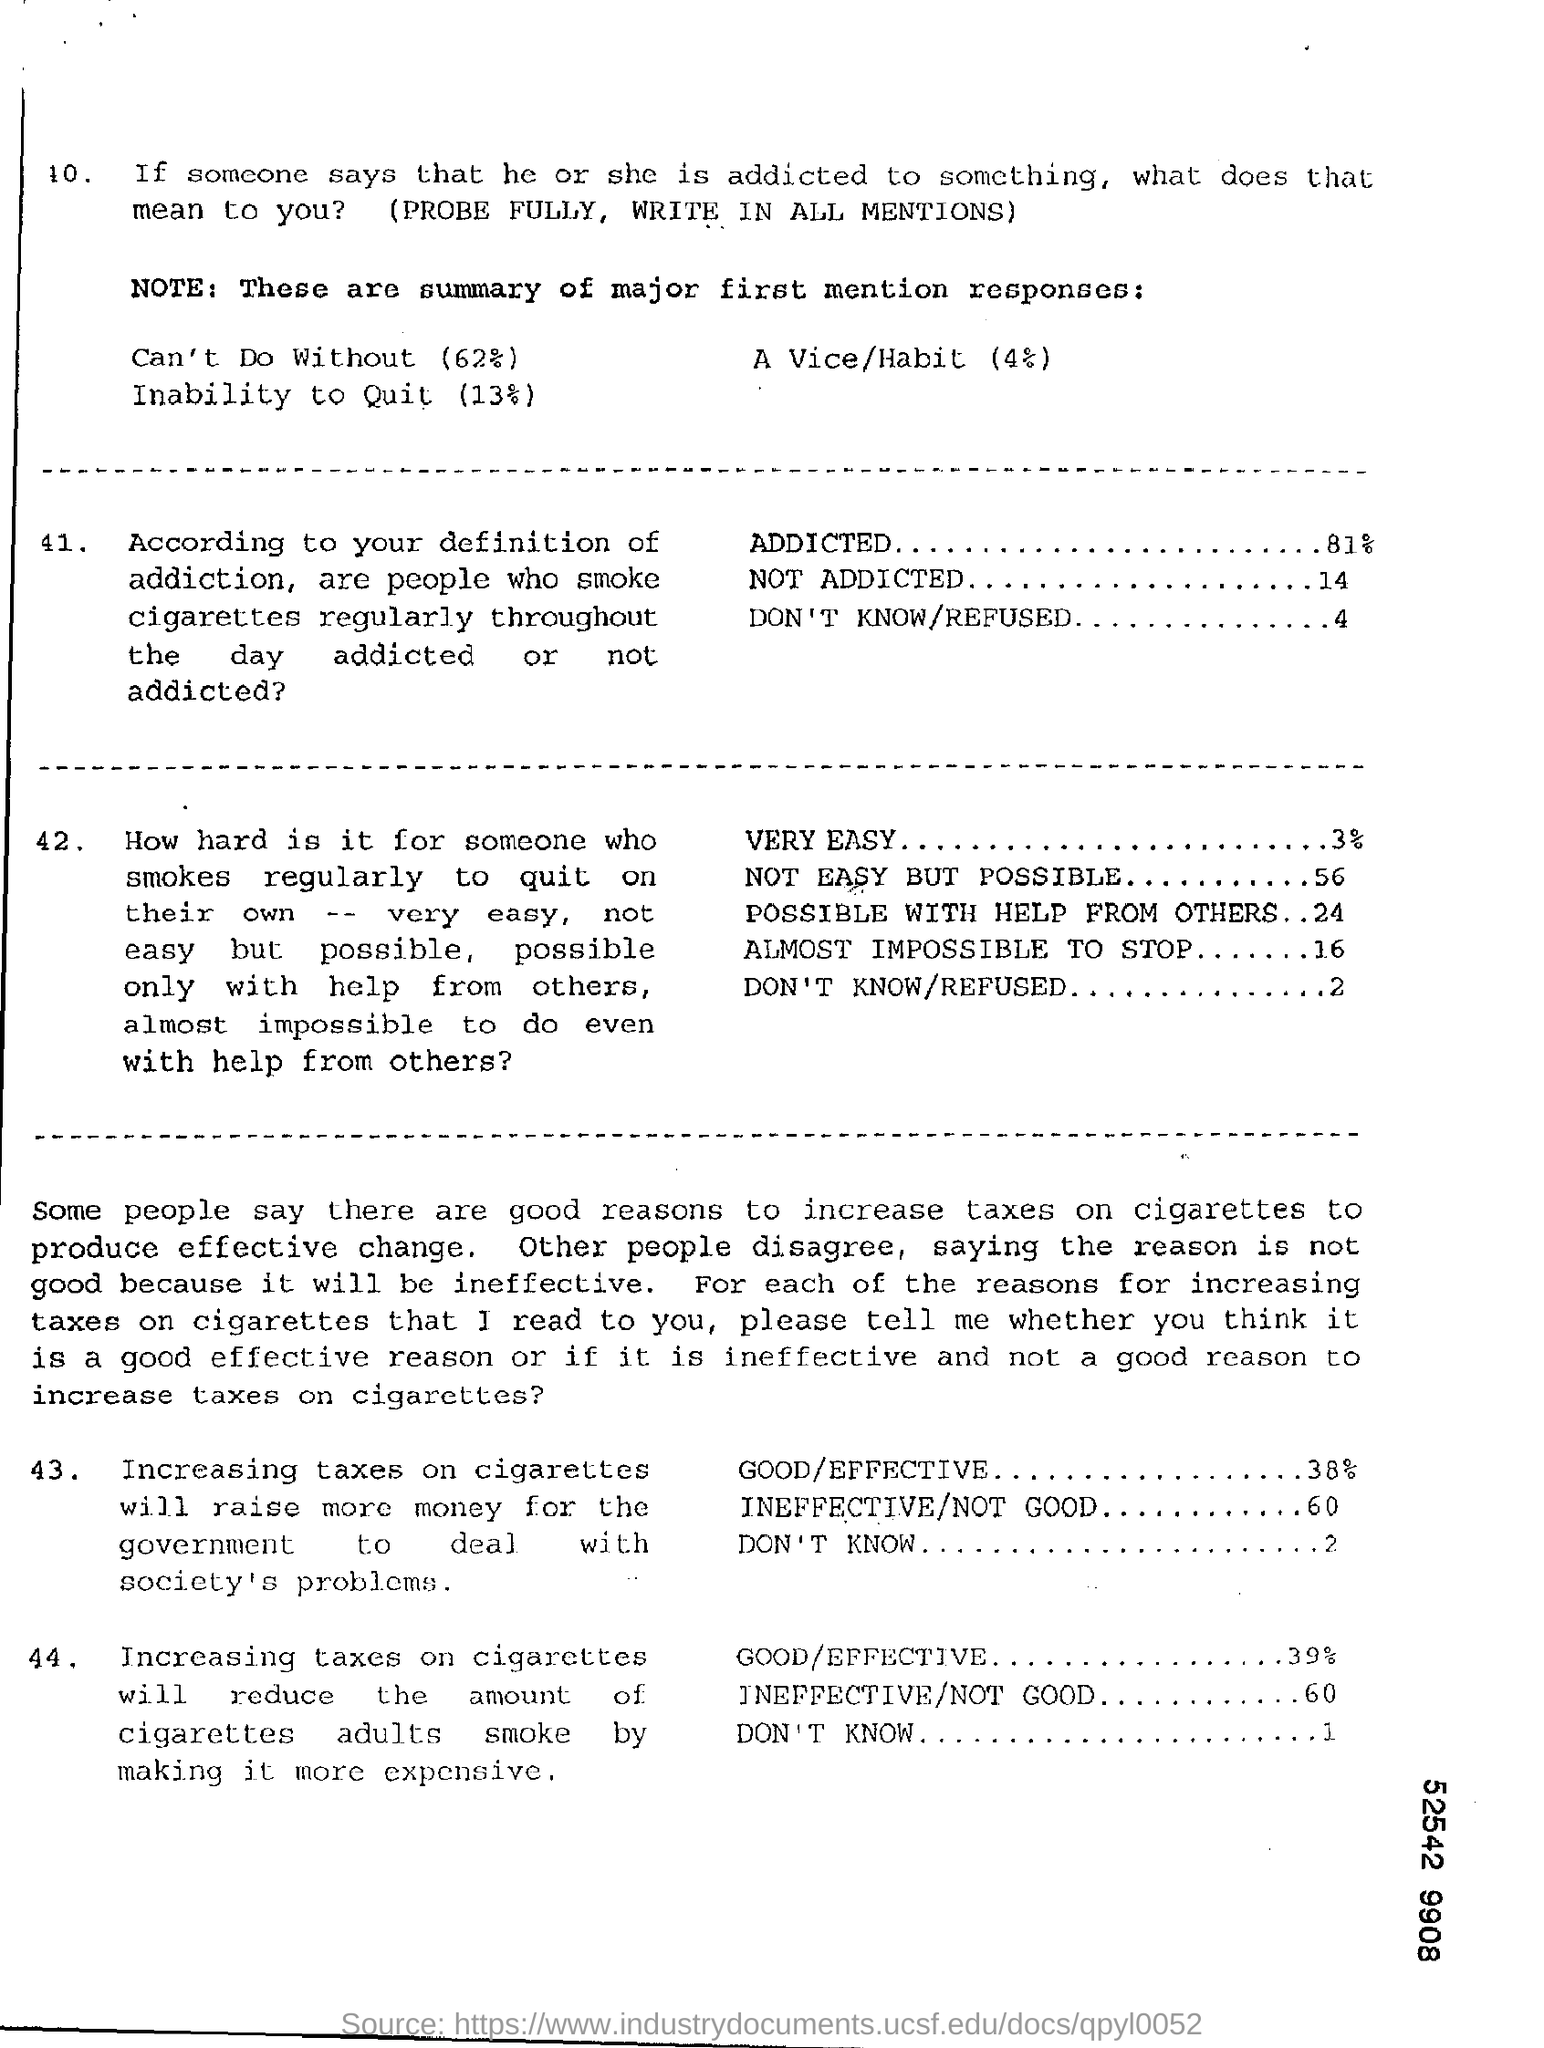Specify some key components in this picture. A survey found that 38% of people believe that increasing taxes on cigarettes will raise more money for the government to deal with society's problems and is considered effective. According to a survey, 81% of people who smoke cigarettes regularly throughout the day are addicted. According to the response, approximately 4% of people are unsure or refuse to answer the question of whether people who smoke cigarettes regularly throughout the day are. According to a survey, 2% of people responded with 'Don't Know' when asked if increasing taxes on cigarettes would raise more money for the government to address society's problems. Sixty percent of the people who responded to the survey believe that increasing taxes on cigarettes is an ineffective way to raise money for the government to address society's problems. 